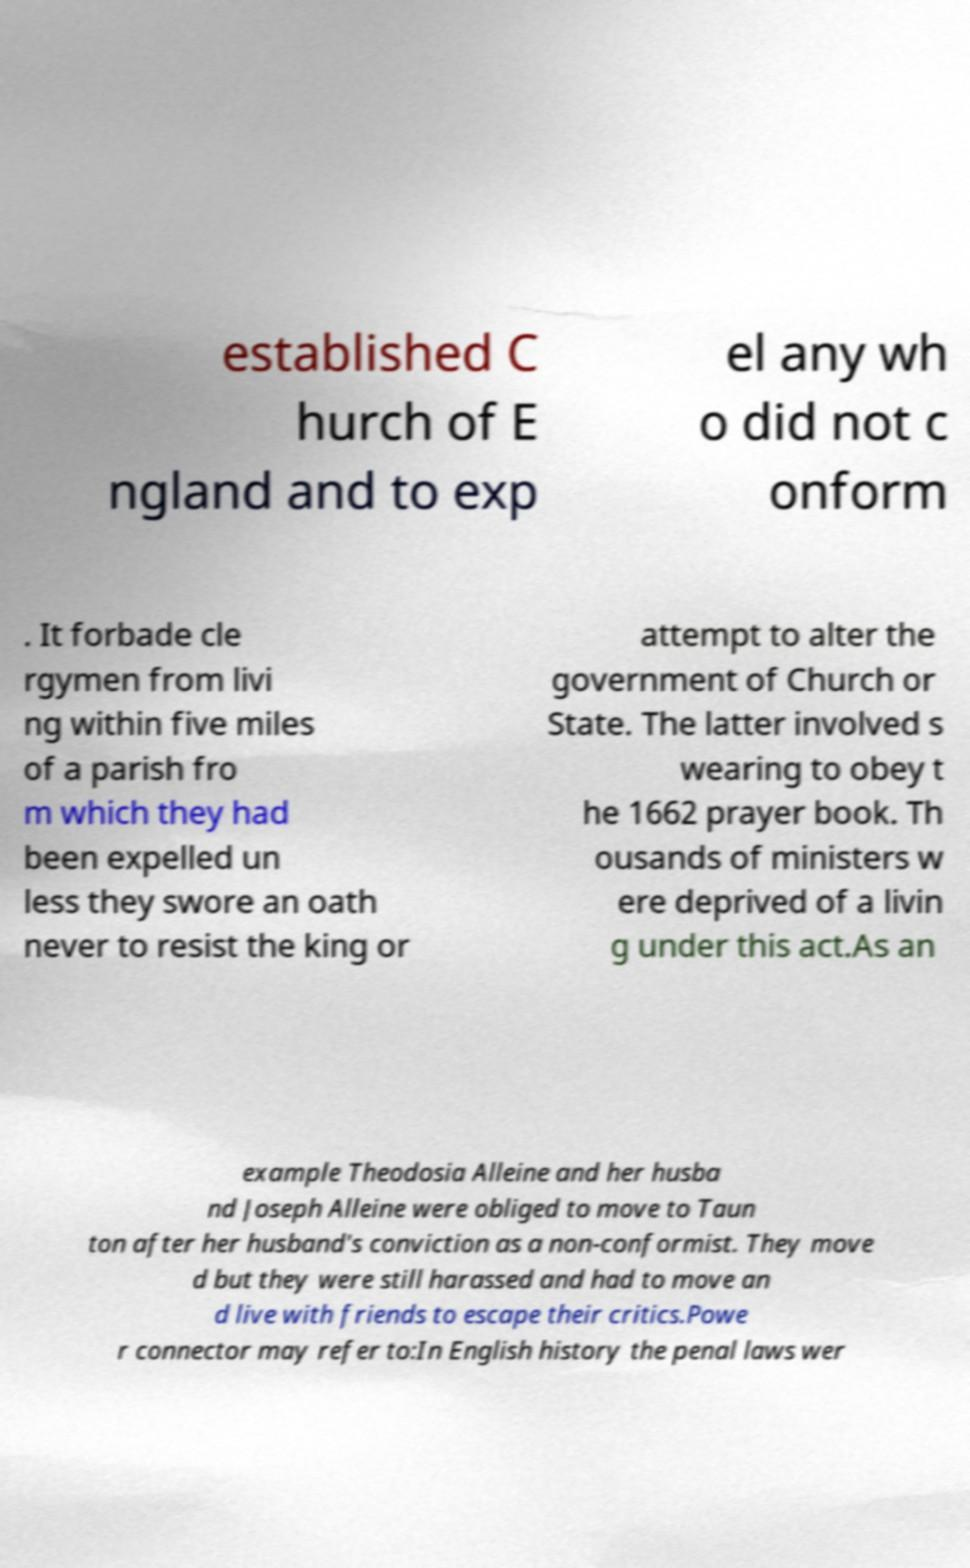Can you accurately transcribe the text from the provided image for me? established C hurch of E ngland and to exp el any wh o did not c onform . It forbade cle rgymen from livi ng within five miles of a parish fro m which they had been expelled un less they swore an oath never to resist the king or attempt to alter the government of Church or State. The latter involved s wearing to obey t he 1662 prayer book. Th ousands of ministers w ere deprived of a livin g under this act.As an example Theodosia Alleine and her husba nd Joseph Alleine were obliged to move to Taun ton after her husband's conviction as a non-conformist. They move d but they were still harassed and had to move an d live with friends to escape their critics.Powe r connector may refer to:In English history the penal laws wer 